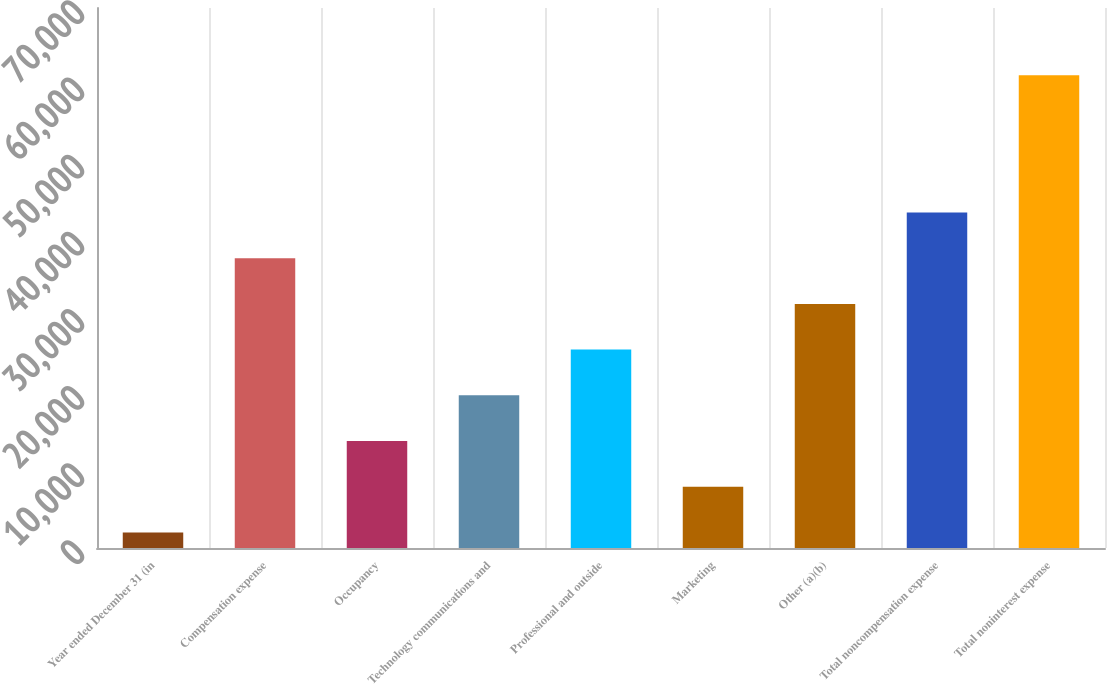Convert chart to OTSL. <chart><loc_0><loc_0><loc_500><loc_500><bar_chart><fcel>Year ended December 31 (in<fcel>Compensation expense<fcel>Occupancy<fcel>Technology communications and<fcel>Professional and outside<fcel>Marketing<fcel>Other (a)(b)<fcel>Total noncompensation expense<fcel>Total noninterest expense<nl><fcel>2014<fcel>37570<fcel>13866<fcel>19792<fcel>25718<fcel>7940<fcel>31644<fcel>43496<fcel>61274<nl></chart> 